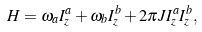<formula> <loc_0><loc_0><loc_500><loc_500>H = \omega _ { a } I _ { z } ^ { a } + \omega _ { b } I _ { z } ^ { b } + 2 \pi J I _ { z } ^ { a } I _ { z } ^ { b } ,</formula> 